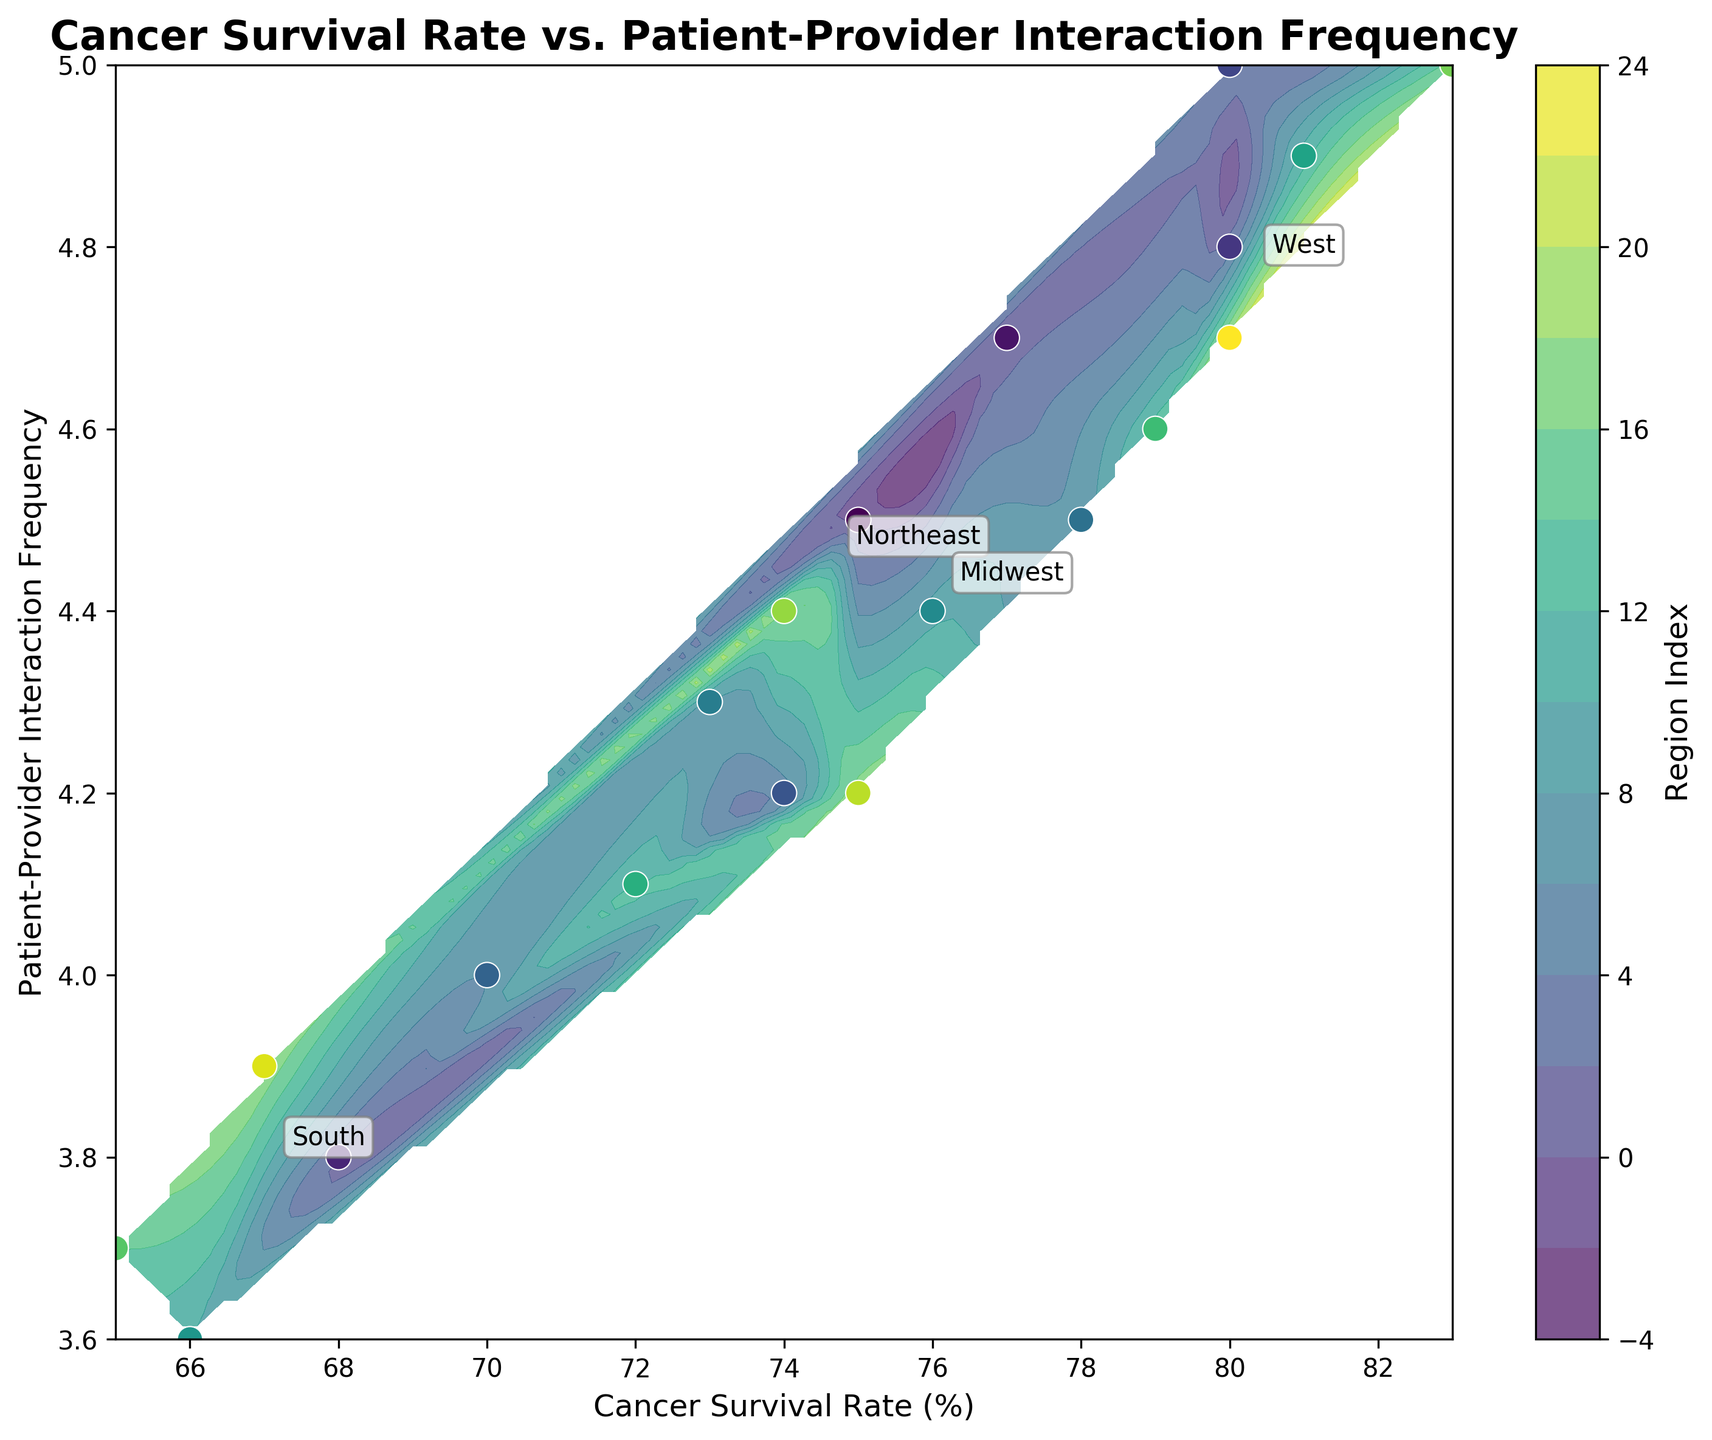What is the title of the plot? The title is located at the top center of the plot and provides a summary of what the figure is about.
Answer: Cancer Survival Rate vs. Patient-Provider Interaction Frequency How many regions are represented in the figure? The figure includes annotations for different regions, which can be counted.
Answer: 4 Which region shows the highest average patient-provider interaction frequency? By comparing the annotated interaction frequencies for each region in the plot, the region with the highest average can be identified.
Answer: West What is the cancer survival rate range for the Northeast region? The figure shows data points for each region, allowing us to identify the minimum and maximum rates in the Northeast region by comparing its points.
Answer: 72-80% Which region has the lowest cancer survival rate? By comparing the lowest cancer survival rate points of each region, the region with the lowest value can be identified.
Answer: South What is the average cancer survival rate for the Midwest region? Calculate the average by summing the cancer survival rates for the Midwest and dividing by the number of data points in this region. The data from the figure must be interpreted and calculated.
Answer: (77 + 74 + 76 + 79 + 75) / 5 = 76.2% Is there a positive correlation between cancer survival rate and patient-provider interaction frequency in the South region? Observe the trend of data points in the South region to see if higher interaction frequency corresponds to higher survival rates and vice versa.
Answer: Yes How does the contour plot represent the grid interpolation? The contour plot uses a color gradient and contour lines to show different levels of an interpolated surface based on the data points. This helps visualize regions of different values across the grid.
Answer: Color gradients and contour lines Which region has the most scattered data points in terms of patient-provider interaction frequency? By observing the spread of data points along the y-axis, the region with the broadest range of interaction frequencies can be identified.
Answer: Northeast 